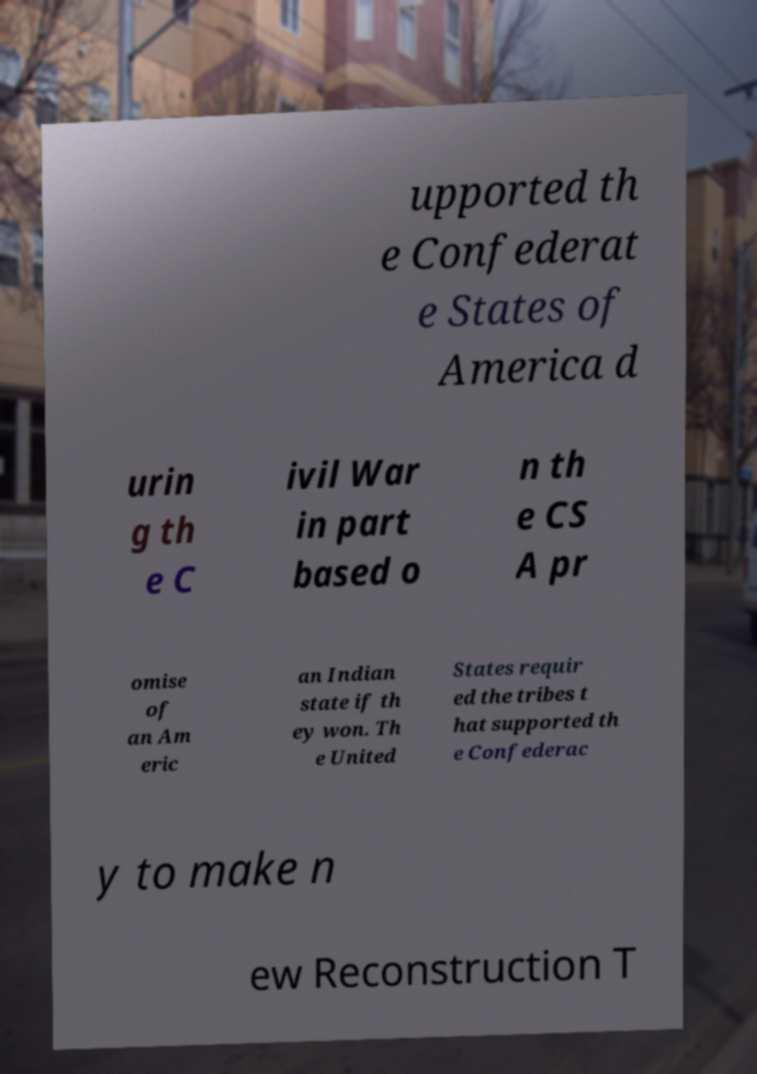Could you extract and type out the text from this image? upported th e Confederat e States of America d urin g th e C ivil War in part based o n th e CS A pr omise of an Am eric an Indian state if th ey won. Th e United States requir ed the tribes t hat supported th e Confederac y to make n ew Reconstruction T 